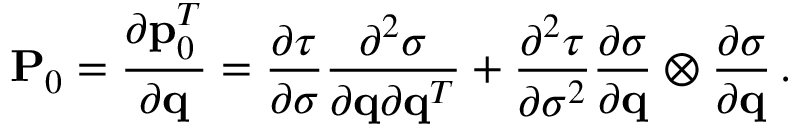Convert formula to latex. <formula><loc_0><loc_0><loc_500><loc_500>{ P } _ { 0 } = \frac { \partial { p } _ { 0 } ^ { T } } { \partial { q } } = \frac { \partial \tau } { \partial \sigma } \frac { \partial ^ { 2 } \sigma } { \partial { q } \partial { q } ^ { T } } + \frac { \partial ^ { 2 } \tau } { \partial \sigma ^ { 2 } } \frac { \partial \sigma } { \partial { q } } \otimes \frac { \partial \sigma } { \partial { q } } \, .</formula> 